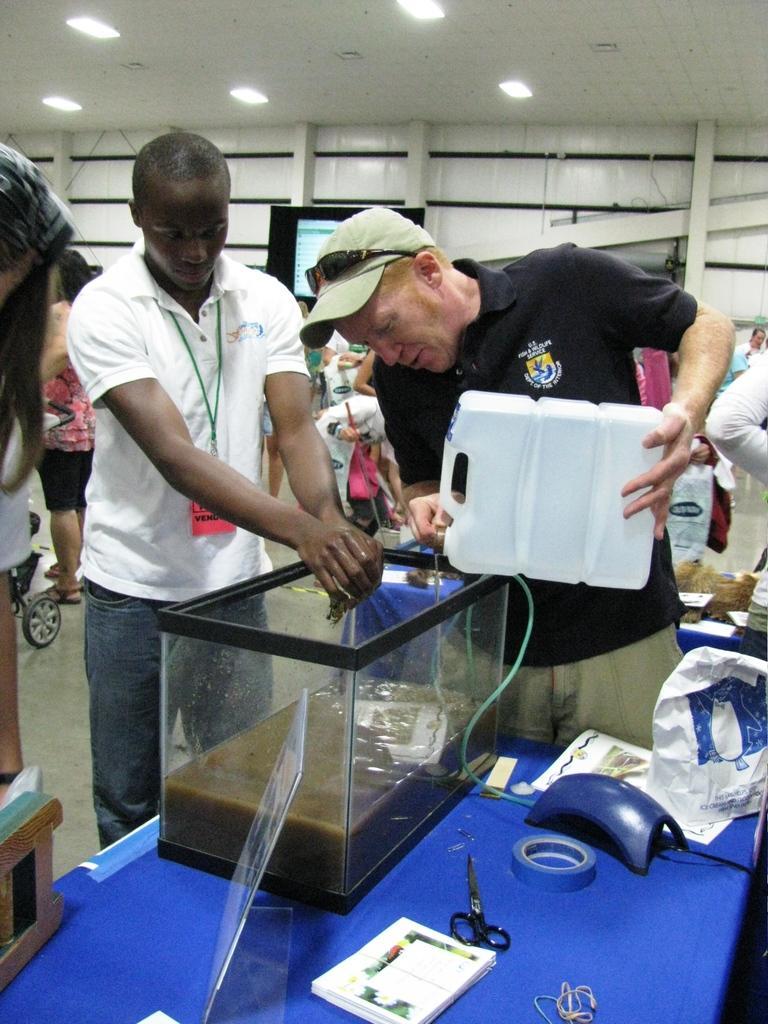Could you give a brief overview of what you see in this image? In the image there is a table and on the table there is a glass box, scissors, plaster and other items, there is some liquid inside the glass box and a person is pouring some fluid into the glass box, beside him there is another person and behind them there are many other people. In the background there is a television fit to the wooden sticks. 